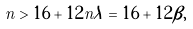<formula> <loc_0><loc_0><loc_500><loc_500>n > 1 6 + 1 2 n \lambda = 1 6 + 1 2 \beta ,</formula> 